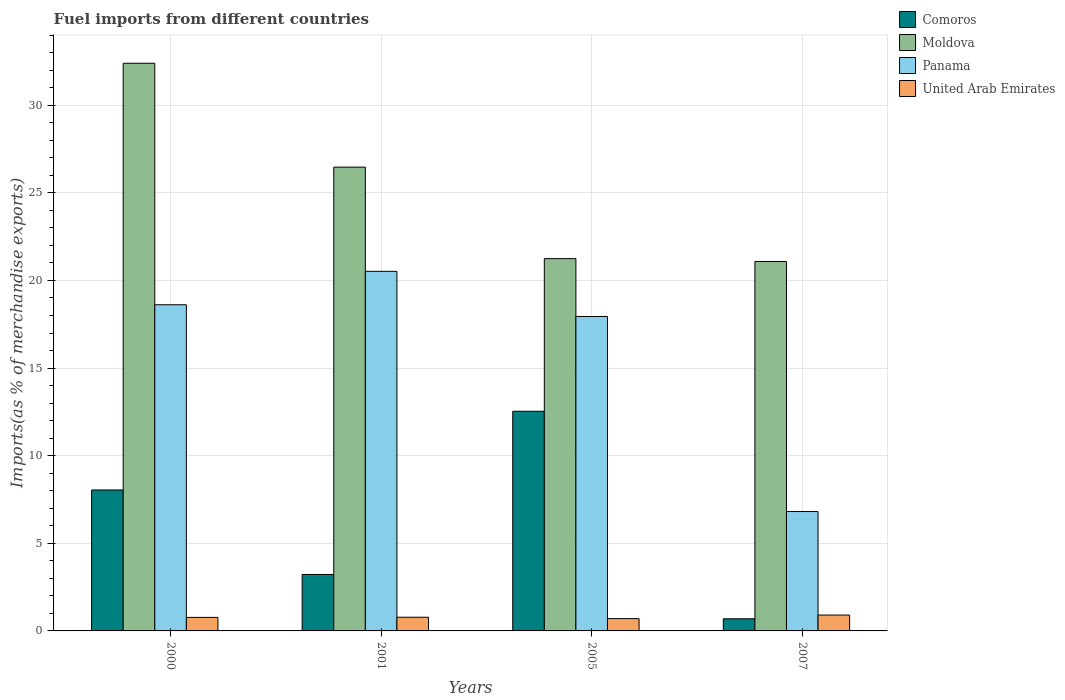In how many cases, is the number of bars for a given year not equal to the number of legend labels?
Your answer should be compact. 0. What is the percentage of imports to different countries in Panama in 2000?
Ensure brevity in your answer.  18.61. Across all years, what is the maximum percentage of imports to different countries in Comoros?
Ensure brevity in your answer.  12.53. Across all years, what is the minimum percentage of imports to different countries in Moldova?
Provide a short and direct response. 21.08. What is the total percentage of imports to different countries in Comoros in the graph?
Provide a succinct answer. 24.49. What is the difference between the percentage of imports to different countries in Comoros in 2000 and that in 2005?
Offer a terse response. -4.49. What is the difference between the percentage of imports to different countries in Comoros in 2000 and the percentage of imports to different countries in Panama in 2005?
Your answer should be very brief. -9.9. What is the average percentage of imports to different countries in Panama per year?
Keep it short and to the point. 15.97. In the year 2000, what is the difference between the percentage of imports to different countries in Moldova and percentage of imports to different countries in Comoros?
Keep it short and to the point. 24.35. In how many years, is the percentage of imports to different countries in Moldova greater than 11 %?
Provide a succinct answer. 4. What is the ratio of the percentage of imports to different countries in United Arab Emirates in 2001 to that in 2007?
Provide a short and direct response. 0.86. Is the percentage of imports to different countries in Comoros in 2000 less than that in 2005?
Your answer should be very brief. Yes. What is the difference between the highest and the second highest percentage of imports to different countries in Moldova?
Give a very brief answer. 5.93. What is the difference between the highest and the lowest percentage of imports to different countries in Comoros?
Offer a terse response. 11.84. In how many years, is the percentage of imports to different countries in Panama greater than the average percentage of imports to different countries in Panama taken over all years?
Ensure brevity in your answer.  3. What does the 4th bar from the left in 2007 represents?
Make the answer very short. United Arab Emirates. What does the 3rd bar from the right in 2000 represents?
Offer a very short reply. Moldova. How many bars are there?
Provide a succinct answer. 16. Are all the bars in the graph horizontal?
Make the answer very short. No. How many years are there in the graph?
Offer a very short reply. 4. What is the difference between two consecutive major ticks on the Y-axis?
Your answer should be compact. 5. Are the values on the major ticks of Y-axis written in scientific E-notation?
Make the answer very short. No. How many legend labels are there?
Give a very brief answer. 4. How are the legend labels stacked?
Keep it short and to the point. Vertical. What is the title of the graph?
Provide a short and direct response. Fuel imports from different countries. What is the label or title of the X-axis?
Your answer should be compact. Years. What is the label or title of the Y-axis?
Ensure brevity in your answer.  Imports(as % of merchandise exports). What is the Imports(as % of merchandise exports) of Comoros in 2000?
Offer a very short reply. 8.04. What is the Imports(as % of merchandise exports) in Moldova in 2000?
Provide a short and direct response. 32.39. What is the Imports(as % of merchandise exports) of Panama in 2000?
Make the answer very short. 18.61. What is the Imports(as % of merchandise exports) of United Arab Emirates in 2000?
Offer a very short reply. 0.77. What is the Imports(as % of merchandise exports) of Comoros in 2001?
Your answer should be compact. 3.22. What is the Imports(as % of merchandise exports) of Moldova in 2001?
Give a very brief answer. 26.47. What is the Imports(as % of merchandise exports) in Panama in 2001?
Your answer should be very brief. 20.52. What is the Imports(as % of merchandise exports) in United Arab Emirates in 2001?
Provide a succinct answer. 0.78. What is the Imports(as % of merchandise exports) in Comoros in 2005?
Provide a succinct answer. 12.53. What is the Imports(as % of merchandise exports) of Moldova in 2005?
Your response must be concise. 21.24. What is the Imports(as % of merchandise exports) of Panama in 2005?
Offer a very short reply. 17.94. What is the Imports(as % of merchandise exports) of United Arab Emirates in 2005?
Your answer should be compact. 0.7. What is the Imports(as % of merchandise exports) of Comoros in 2007?
Ensure brevity in your answer.  0.69. What is the Imports(as % of merchandise exports) of Moldova in 2007?
Give a very brief answer. 21.08. What is the Imports(as % of merchandise exports) of Panama in 2007?
Provide a succinct answer. 6.81. What is the Imports(as % of merchandise exports) of United Arab Emirates in 2007?
Your answer should be very brief. 0.91. Across all years, what is the maximum Imports(as % of merchandise exports) of Comoros?
Ensure brevity in your answer.  12.53. Across all years, what is the maximum Imports(as % of merchandise exports) in Moldova?
Your answer should be very brief. 32.39. Across all years, what is the maximum Imports(as % of merchandise exports) of Panama?
Your answer should be compact. 20.52. Across all years, what is the maximum Imports(as % of merchandise exports) of United Arab Emirates?
Ensure brevity in your answer.  0.91. Across all years, what is the minimum Imports(as % of merchandise exports) of Comoros?
Ensure brevity in your answer.  0.69. Across all years, what is the minimum Imports(as % of merchandise exports) in Moldova?
Provide a succinct answer. 21.08. Across all years, what is the minimum Imports(as % of merchandise exports) in Panama?
Provide a succinct answer. 6.81. Across all years, what is the minimum Imports(as % of merchandise exports) of United Arab Emirates?
Offer a very short reply. 0.7. What is the total Imports(as % of merchandise exports) in Comoros in the graph?
Your answer should be compact. 24.49. What is the total Imports(as % of merchandise exports) in Moldova in the graph?
Keep it short and to the point. 101.18. What is the total Imports(as % of merchandise exports) in Panama in the graph?
Offer a terse response. 63.89. What is the total Imports(as % of merchandise exports) in United Arab Emirates in the graph?
Offer a very short reply. 3.16. What is the difference between the Imports(as % of merchandise exports) in Comoros in 2000 and that in 2001?
Offer a very short reply. 4.82. What is the difference between the Imports(as % of merchandise exports) in Moldova in 2000 and that in 2001?
Ensure brevity in your answer.  5.93. What is the difference between the Imports(as % of merchandise exports) in Panama in 2000 and that in 2001?
Ensure brevity in your answer.  -1.91. What is the difference between the Imports(as % of merchandise exports) in United Arab Emirates in 2000 and that in 2001?
Give a very brief answer. -0.01. What is the difference between the Imports(as % of merchandise exports) of Comoros in 2000 and that in 2005?
Ensure brevity in your answer.  -4.49. What is the difference between the Imports(as % of merchandise exports) of Moldova in 2000 and that in 2005?
Offer a very short reply. 11.15. What is the difference between the Imports(as % of merchandise exports) in Panama in 2000 and that in 2005?
Make the answer very short. 0.67. What is the difference between the Imports(as % of merchandise exports) in United Arab Emirates in 2000 and that in 2005?
Offer a terse response. 0.07. What is the difference between the Imports(as % of merchandise exports) in Comoros in 2000 and that in 2007?
Your answer should be compact. 7.35. What is the difference between the Imports(as % of merchandise exports) of Moldova in 2000 and that in 2007?
Your response must be concise. 11.31. What is the difference between the Imports(as % of merchandise exports) in Panama in 2000 and that in 2007?
Provide a succinct answer. 11.8. What is the difference between the Imports(as % of merchandise exports) in United Arab Emirates in 2000 and that in 2007?
Offer a very short reply. -0.13. What is the difference between the Imports(as % of merchandise exports) in Comoros in 2001 and that in 2005?
Make the answer very short. -9.31. What is the difference between the Imports(as % of merchandise exports) in Moldova in 2001 and that in 2005?
Make the answer very short. 5.22. What is the difference between the Imports(as % of merchandise exports) of Panama in 2001 and that in 2005?
Your answer should be compact. 2.57. What is the difference between the Imports(as % of merchandise exports) in United Arab Emirates in 2001 and that in 2005?
Keep it short and to the point. 0.08. What is the difference between the Imports(as % of merchandise exports) of Comoros in 2001 and that in 2007?
Ensure brevity in your answer.  2.53. What is the difference between the Imports(as % of merchandise exports) of Moldova in 2001 and that in 2007?
Your answer should be very brief. 5.38. What is the difference between the Imports(as % of merchandise exports) of Panama in 2001 and that in 2007?
Your response must be concise. 13.71. What is the difference between the Imports(as % of merchandise exports) of United Arab Emirates in 2001 and that in 2007?
Keep it short and to the point. -0.12. What is the difference between the Imports(as % of merchandise exports) of Comoros in 2005 and that in 2007?
Ensure brevity in your answer.  11.84. What is the difference between the Imports(as % of merchandise exports) in Moldova in 2005 and that in 2007?
Offer a terse response. 0.16. What is the difference between the Imports(as % of merchandise exports) in Panama in 2005 and that in 2007?
Ensure brevity in your answer.  11.13. What is the difference between the Imports(as % of merchandise exports) in United Arab Emirates in 2005 and that in 2007?
Provide a succinct answer. -0.2. What is the difference between the Imports(as % of merchandise exports) of Comoros in 2000 and the Imports(as % of merchandise exports) of Moldova in 2001?
Provide a short and direct response. -18.42. What is the difference between the Imports(as % of merchandise exports) of Comoros in 2000 and the Imports(as % of merchandise exports) of Panama in 2001?
Ensure brevity in your answer.  -12.47. What is the difference between the Imports(as % of merchandise exports) in Comoros in 2000 and the Imports(as % of merchandise exports) in United Arab Emirates in 2001?
Ensure brevity in your answer.  7.26. What is the difference between the Imports(as % of merchandise exports) in Moldova in 2000 and the Imports(as % of merchandise exports) in Panama in 2001?
Offer a very short reply. 11.87. What is the difference between the Imports(as % of merchandise exports) in Moldova in 2000 and the Imports(as % of merchandise exports) in United Arab Emirates in 2001?
Offer a terse response. 31.61. What is the difference between the Imports(as % of merchandise exports) in Panama in 2000 and the Imports(as % of merchandise exports) in United Arab Emirates in 2001?
Your answer should be very brief. 17.83. What is the difference between the Imports(as % of merchandise exports) in Comoros in 2000 and the Imports(as % of merchandise exports) in Moldova in 2005?
Provide a succinct answer. -13.2. What is the difference between the Imports(as % of merchandise exports) in Comoros in 2000 and the Imports(as % of merchandise exports) in Panama in 2005?
Ensure brevity in your answer.  -9.9. What is the difference between the Imports(as % of merchandise exports) in Comoros in 2000 and the Imports(as % of merchandise exports) in United Arab Emirates in 2005?
Give a very brief answer. 7.34. What is the difference between the Imports(as % of merchandise exports) in Moldova in 2000 and the Imports(as % of merchandise exports) in Panama in 2005?
Your response must be concise. 14.45. What is the difference between the Imports(as % of merchandise exports) of Moldova in 2000 and the Imports(as % of merchandise exports) of United Arab Emirates in 2005?
Your answer should be compact. 31.69. What is the difference between the Imports(as % of merchandise exports) in Panama in 2000 and the Imports(as % of merchandise exports) in United Arab Emirates in 2005?
Provide a short and direct response. 17.91. What is the difference between the Imports(as % of merchandise exports) in Comoros in 2000 and the Imports(as % of merchandise exports) in Moldova in 2007?
Ensure brevity in your answer.  -13.04. What is the difference between the Imports(as % of merchandise exports) of Comoros in 2000 and the Imports(as % of merchandise exports) of Panama in 2007?
Your answer should be very brief. 1.23. What is the difference between the Imports(as % of merchandise exports) in Comoros in 2000 and the Imports(as % of merchandise exports) in United Arab Emirates in 2007?
Provide a succinct answer. 7.14. What is the difference between the Imports(as % of merchandise exports) in Moldova in 2000 and the Imports(as % of merchandise exports) in Panama in 2007?
Ensure brevity in your answer.  25.58. What is the difference between the Imports(as % of merchandise exports) in Moldova in 2000 and the Imports(as % of merchandise exports) in United Arab Emirates in 2007?
Ensure brevity in your answer.  31.49. What is the difference between the Imports(as % of merchandise exports) of Panama in 2000 and the Imports(as % of merchandise exports) of United Arab Emirates in 2007?
Ensure brevity in your answer.  17.71. What is the difference between the Imports(as % of merchandise exports) in Comoros in 2001 and the Imports(as % of merchandise exports) in Moldova in 2005?
Offer a very short reply. -18.02. What is the difference between the Imports(as % of merchandise exports) of Comoros in 2001 and the Imports(as % of merchandise exports) of Panama in 2005?
Your answer should be very brief. -14.72. What is the difference between the Imports(as % of merchandise exports) of Comoros in 2001 and the Imports(as % of merchandise exports) of United Arab Emirates in 2005?
Offer a very short reply. 2.52. What is the difference between the Imports(as % of merchandise exports) in Moldova in 2001 and the Imports(as % of merchandise exports) in Panama in 2005?
Your answer should be very brief. 8.52. What is the difference between the Imports(as % of merchandise exports) in Moldova in 2001 and the Imports(as % of merchandise exports) in United Arab Emirates in 2005?
Give a very brief answer. 25.76. What is the difference between the Imports(as % of merchandise exports) in Panama in 2001 and the Imports(as % of merchandise exports) in United Arab Emirates in 2005?
Make the answer very short. 19.82. What is the difference between the Imports(as % of merchandise exports) in Comoros in 2001 and the Imports(as % of merchandise exports) in Moldova in 2007?
Provide a short and direct response. -17.86. What is the difference between the Imports(as % of merchandise exports) of Comoros in 2001 and the Imports(as % of merchandise exports) of Panama in 2007?
Give a very brief answer. -3.59. What is the difference between the Imports(as % of merchandise exports) of Comoros in 2001 and the Imports(as % of merchandise exports) of United Arab Emirates in 2007?
Offer a terse response. 2.32. What is the difference between the Imports(as % of merchandise exports) in Moldova in 2001 and the Imports(as % of merchandise exports) in Panama in 2007?
Provide a short and direct response. 19.65. What is the difference between the Imports(as % of merchandise exports) of Moldova in 2001 and the Imports(as % of merchandise exports) of United Arab Emirates in 2007?
Give a very brief answer. 25.56. What is the difference between the Imports(as % of merchandise exports) in Panama in 2001 and the Imports(as % of merchandise exports) in United Arab Emirates in 2007?
Keep it short and to the point. 19.61. What is the difference between the Imports(as % of merchandise exports) of Comoros in 2005 and the Imports(as % of merchandise exports) of Moldova in 2007?
Provide a short and direct response. -8.55. What is the difference between the Imports(as % of merchandise exports) in Comoros in 2005 and the Imports(as % of merchandise exports) in Panama in 2007?
Your response must be concise. 5.72. What is the difference between the Imports(as % of merchandise exports) in Comoros in 2005 and the Imports(as % of merchandise exports) in United Arab Emirates in 2007?
Ensure brevity in your answer.  11.63. What is the difference between the Imports(as % of merchandise exports) of Moldova in 2005 and the Imports(as % of merchandise exports) of Panama in 2007?
Give a very brief answer. 14.43. What is the difference between the Imports(as % of merchandise exports) of Moldova in 2005 and the Imports(as % of merchandise exports) of United Arab Emirates in 2007?
Provide a succinct answer. 20.34. What is the difference between the Imports(as % of merchandise exports) of Panama in 2005 and the Imports(as % of merchandise exports) of United Arab Emirates in 2007?
Offer a terse response. 17.04. What is the average Imports(as % of merchandise exports) of Comoros per year?
Your response must be concise. 6.12. What is the average Imports(as % of merchandise exports) of Moldova per year?
Your answer should be compact. 25.3. What is the average Imports(as % of merchandise exports) of Panama per year?
Provide a succinct answer. 15.97. What is the average Imports(as % of merchandise exports) of United Arab Emirates per year?
Offer a very short reply. 0.79. In the year 2000, what is the difference between the Imports(as % of merchandise exports) in Comoros and Imports(as % of merchandise exports) in Moldova?
Give a very brief answer. -24.35. In the year 2000, what is the difference between the Imports(as % of merchandise exports) in Comoros and Imports(as % of merchandise exports) in Panama?
Provide a short and direct response. -10.57. In the year 2000, what is the difference between the Imports(as % of merchandise exports) of Comoros and Imports(as % of merchandise exports) of United Arab Emirates?
Ensure brevity in your answer.  7.27. In the year 2000, what is the difference between the Imports(as % of merchandise exports) of Moldova and Imports(as % of merchandise exports) of Panama?
Keep it short and to the point. 13.78. In the year 2000, what is the difference between the Imports(as % of merchandise exports) of Moldova and Imports(as % of merchandise exports) of United Arab Emirates?
Your answer should be compact. 31.62. In the year 2000, what is the difference between the Imports(as % of merchandise exports) in Panama and Imports(as % of merchandise exports) in United Arab Emirates?
Keep it short and to the point. 17.84. In the year 2001, what is the difference between the Imports(as % of merchandise exports) in Comoros and Imports(as % of merchandise exports) in Moldova?
Make the answer very short. -23.24. In the year 2001, what is the difference between the Imports(as % of merchandise exports) of Comoros and Imports(as % of merchandise exports) of Panama?
Your response must be concise. -17.3. In the year 2001, what is the difference between the Imports(as % of merchandise exports) in Comoros and Imports(as % of merchandise exports) in United Arab Emirates?
Provide a short and direct response. 2.44. In the year 2001, what is the difference between the Imports(as % of merchandise exports) in Moldova and Imports(as % of merchandise exports) in Panama?
Your response must be concise. 5.95. In the year 2001, what is the difference between the Imports(as % of merchandise exports) of Moldova and Imports(as % of merchandise exports) of United Arab Emirates?
Keep it short and to the point. 25.68. In the year 2001, what is the difference between the Imports(as % of merchandise exports) in Panama and Imports(as % of merchandise exports) in United Arab Emirates?
Provide a short and direct response. 19.74. In the year 2005, what is the difference between the Imports(as % of merchandise exports) of Comoros and Imports(as % of merchandise exports) of Moldova?
Give a very brief answer. -8.71. In the year 2005, what is the difference between the Imports(as % of merchandise exports) of Comoros and Imports(as % of merchandise exports) of Panama?
Your answer should be very brief. -5.41. In the year 2005, what is the difference between the Imports(as % of merchandise exports) of Comoros and Imports(as % of merchandise exports) of United Arab Emirates?
Offer a terse response. 11.83. In the year 2005, what is the difference between the Imports(as % of merchandise exports) of Moldova and Imports(as % of merchandise exports) of Panama?
Your answer should be compact. 3.3. In the year 2005, what is the difference between the Imports(as % of merchandise exports) of Moldova and Imports(as % of merchandise exports) of United Arab Emirates?
Give a very brief answer. 20.54. In the year 2005, what is the difference between the Imports(as % of merchandise exports) of Panama and Imports(as % of merchandise exports) of United Arab Emirates?
Provide a succinct answer. 17.24. In the year 2007, what is the difference between the Imports(as % of merchandise exports) in Comoros and Imports(as % of merchandise exports) in Moldova?
Make the answer very short. -20.39. In the year 2007, what is the difference between the Imports(as % of merchandise exports) of Comoros and Imports(as % of merchandise exports) of Panama?
Provide a short and direct response. -6.12. In the year 2007, what is the difference between the Imports(as % of merchandise exports) in Comoros and Imports(as % of merchandise exports) in United Arab Emirates?
Ensure brevity in your answer.  -0.21. In the year 2007, what is the difference between the Imports(as % of merchandise exports) of Moldova and Imports(as % of merchandise exports) of Panama?
Make the answer very short. 14.27. In the year 2007, what is the difference between the Imports(as % of merchandise exports) of Moldova and Imports(as % of merchandise exports) of United Arab Emirates?
Your response must be concise. 20.18. In the year 2007, what is the difference between the Imports(as % of merchandise exports) in Panama and Imports(as % of merchandise exports) in United Arab Emirates?
Make the answer very short. 5.91. What is the ratio of the Imports(as % of merchandise exports) of Comoros in 2000 to that in 2001?
Ensure brevity in your answer.  2.5. What is the ratio of the Imports(as % of merchandise exports) in Moldova in 2000 to that in 2001?
Your answer should be very brief. 1.22. What is the ratio of the Imports(as % of merchandise exports) of Panama in 2000 to that in 2001?
Provide a short and direct response. 0.91. What is the ratio of the Imports(as % of merchandise exports) of Comoros in 2000 to that in 2005?
Your answer should be compact. 0.64. What is the ratio of the Imports(as % of merchandise exports) of Moldova in 2000 to that in 2005?
Ensure brevity in your answer.  1.52. What is the ratio of the Imports(as % of merchandise exports) in Panama in 2000 to that in 2005?
Your answer should be compact. 1.04. What is the ratio of the Imports(as % of merchandise exports) in United Arab Emirates in 2000 to that in 2005?
Your answer should be very brief. 1.1. What is the ratio of the Imports(as % of merchandise exports) in Comoros in 2000 to that in 2007?
Provide a succinct answer. 11.61. What is the ratio of the Imports(as % of merchandise exports) in Moldova in 2000 to that in 2007?
Provide a succinct answer. 1.54. What is the ratio of the Imports(as % of merchandise exports) of Panama in 2000 to that in 2007?
Your answer should be compact. 2.73. What is the ratio of the Imports(as % of merchandise exports) in United Arab Emirates in 2000 to that in 2007?
Keep it short and to the point. 0.85. What is the ratio of the Imports(as % of merchandise exports) of Comoros in 2001 to that in 2005?
Offer a very short reply. 0.26. What is the ratio of the Imports(as % of merchandise exports) of Moldova in 2001 to that in 2005?
Ensure brevity in your answer.  1.25. What is the ratio of the Imports(as % of merchandise exports) in Panama in 2001 to that in 2005?
Your answer should be very brief. 1.14. What is the ratio of the Imports(as % of merchandise exports) in United Arab Emirates in 2001 to that in 2005?
Offer a terse response. 1.11. What is the ratio of the Imports(as % of merchandise exports) of Comoros in 2001 to that in 2007?
Provide a short and direct response. 4.65. What is the ratio of the Imports(as % of merchandise exports) of Moldova in 2001 to that in 2007?
Provide a succinct answer. 1.26. What is the ratio of the Imports(as % of merchandise exports) of Panama in 2001 to that in 2007?
Your response must be concise. 3.01. What is the ratio of the Imports(as % of merchandise exports) in United Arab Emirates in 2001 to that in 2007?
Offer a terse response. 0.86. What is the ratio of the Imports(as % of merchandise exports) in Comoros in 2005 to that in 2007?
Keep it short and to the point. 18.1. What is the ratio of the Imports(as % of merchandise exports) of Moldova in 2005 to that in 2007?
Provide a short and direct response. 1.01. What is the ratio of the Imports(as % of merchandise exports) in Panama in 2005 to that in 2007?
Ensure brevity in your answer.  2.63. What is the ratio of the Imports(as % of merchandise exports) in United Arab Emirates in 2005 to that in 2007?
Make the answer very short. 0.78. What is the difference between the highest and the second highest Imports(as % of merchandise exports) of Comoros?
Keep it short and to the point. 4.49. What is the difference between the highest and the second highest Imports(as % of merchandise exports) in Moldova?
Your answer should be very brief. 5.93. What is the difference between the highest and the second highest Imports(as % of merchandise exports) in Panama?
Your answer should be very brief. 1.91. What is the difference between the highest and the second highest Imports(as % of merchandise exports) in United Arab Emirates?
Give a very brief answer. 0.12. What is the difference between the highest and the lowest Imports(as % of merchandise exports) of Comoros?
Keep it short and to the point. 11.84. What is the difference between the highest and the lowest Imports(as % of merchandise exports) of Moldova?
Provide a short and direct response. 11.31. What is the difference between the highest and the lowest Imports(as % of merchandise exports) of Panama?
Keep it short and to the point. 13.71. What is the difference between the highest and the lowest Imports(as % of merchandise exports) of United Arab Emirates?
Ensure brevity in your answer.  0.2. 